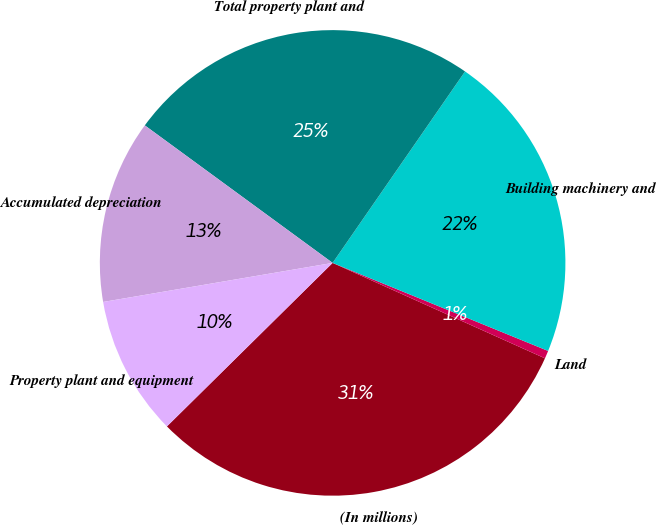<chart> <loc_0><loc_0><loc_500><loc_500><pie_chart><fcel>(In millions)<fcel>Land<fcel>Building machinery and<fcel>Total property plant and<fcel>Accumulated depreciation<fcel>Property plant and equipment<nl><fcel>30.88%<fcel>0.55%<fcel>21.54%<fcel>24.57%<fcel>12.74%<fcel>9.71%<nl></chart> 